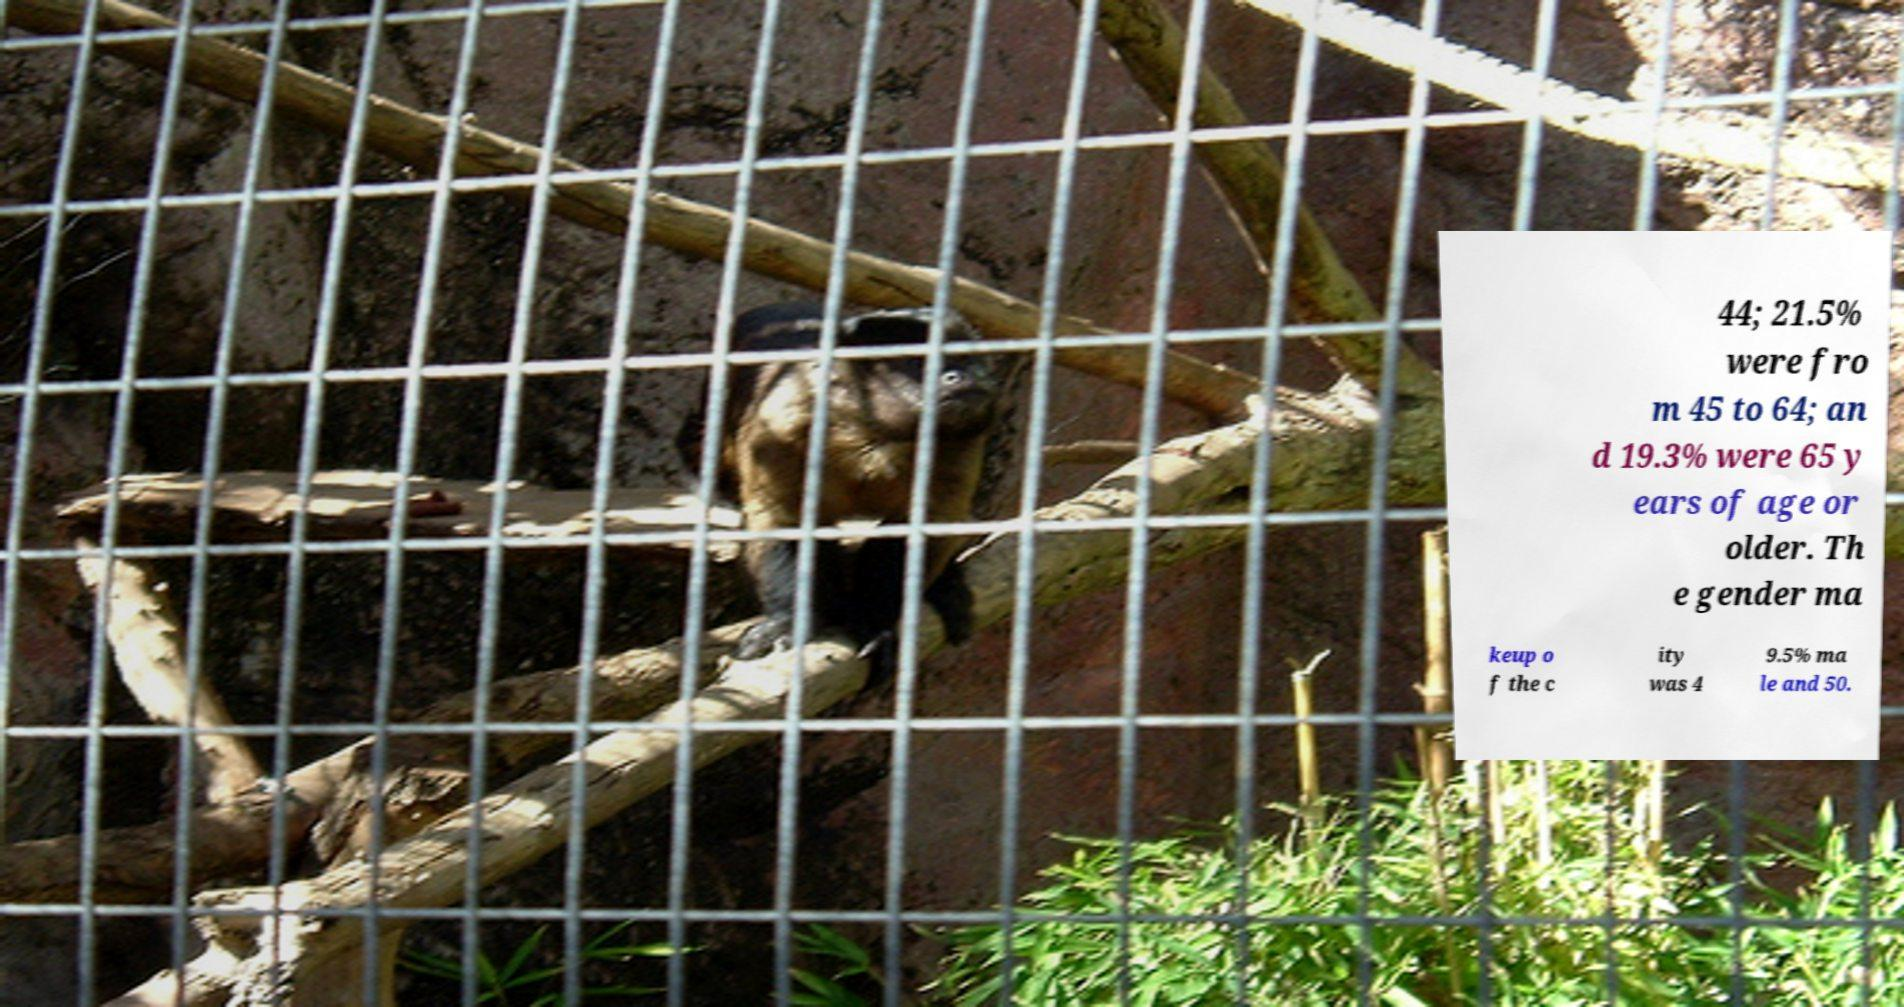There's text embedded in this image that I need extracted. Can you transcribe it verbatim? 44; 21.5% were fro m 45 to 64; an d 19.3% were 65 y ears of age or older. Th e gender ma keup o f the c ity was 4 9.5% ma le and 50. 